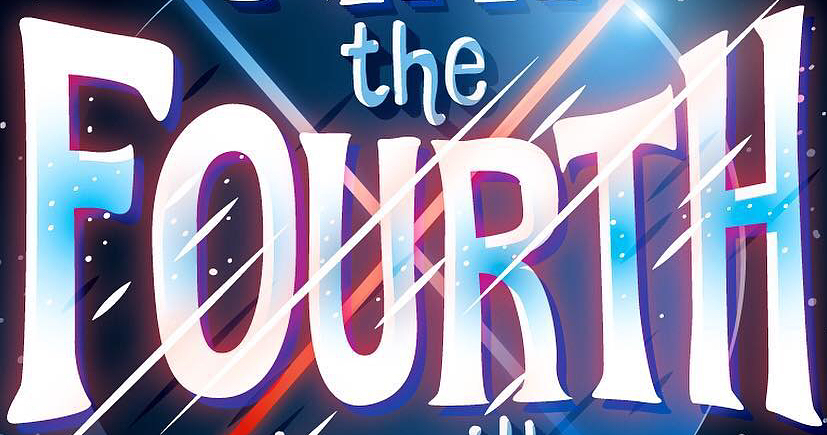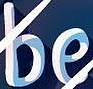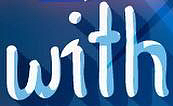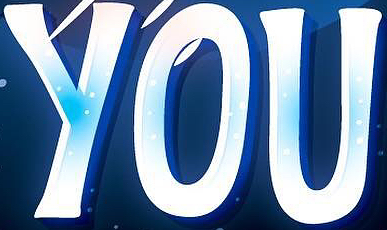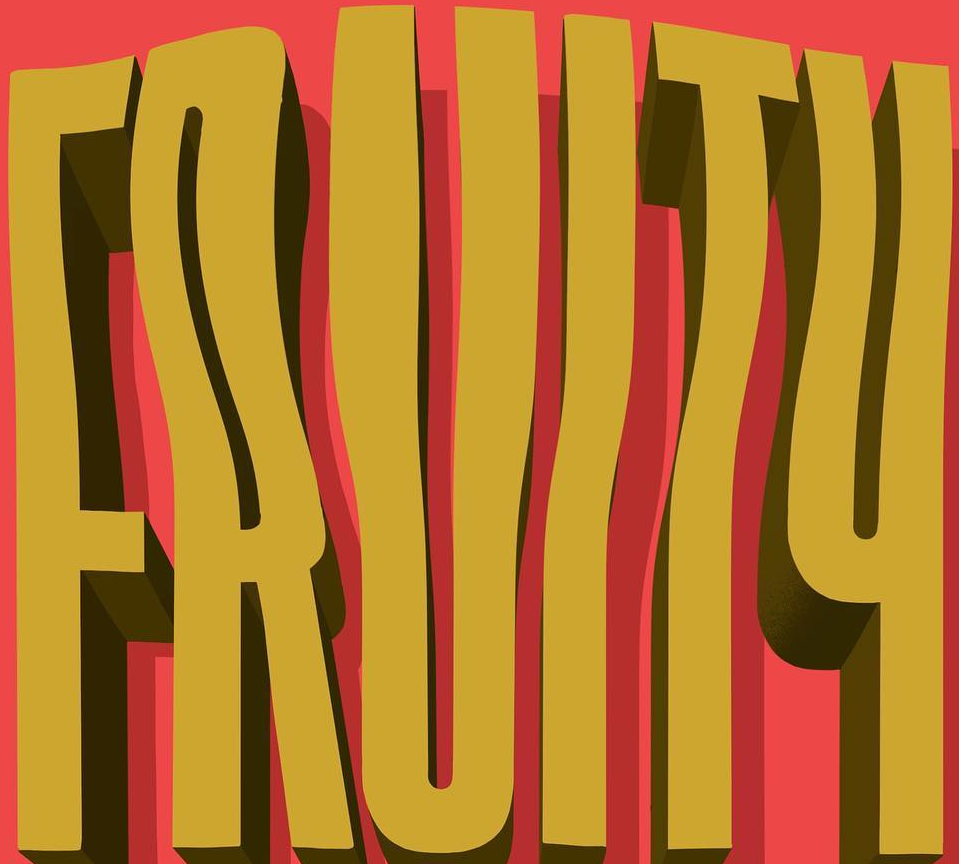What words are shown in these images in order, separated by a semicolon? FOURTH; be; with; YOU; FRUITY 